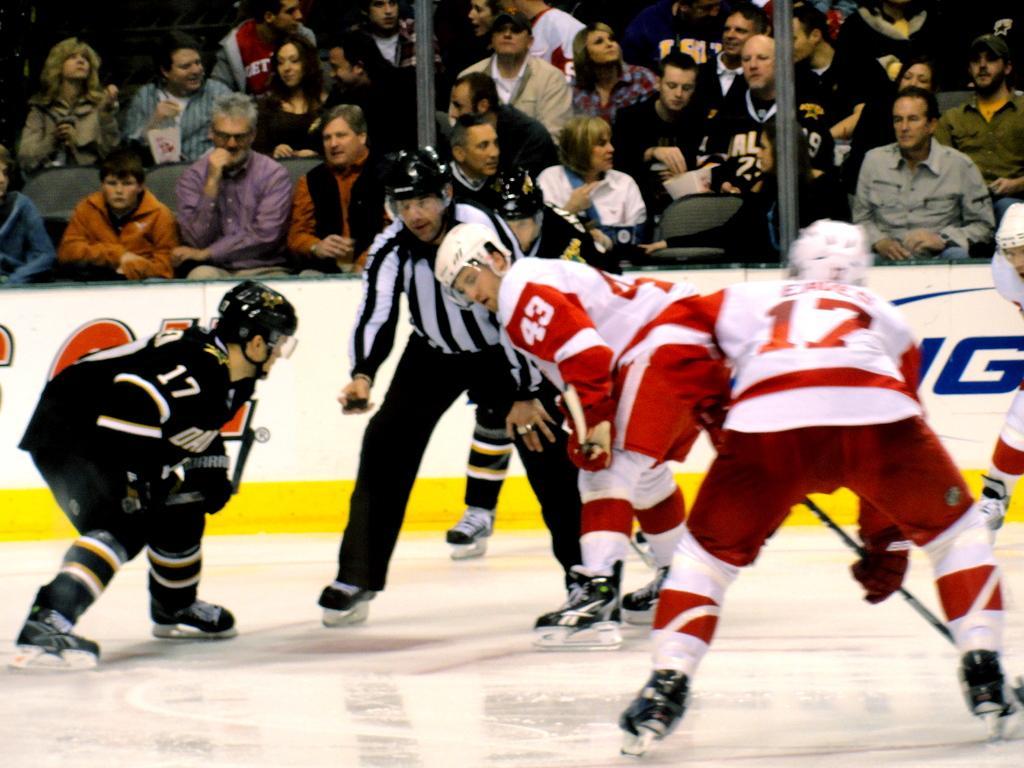Please provide a concise description of this image. In this image I can see group of people playing game. In front the person is wearing white and red color dress and holding a stick. Background I can see few persons sitting and I can see the board in white and yellow color. 